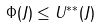Convert formula to latex. <formula><loc_0><loc_0><loc_500><loc_500>\Phi ( J ) \leq U ^ { * * } ( J )</formula> 